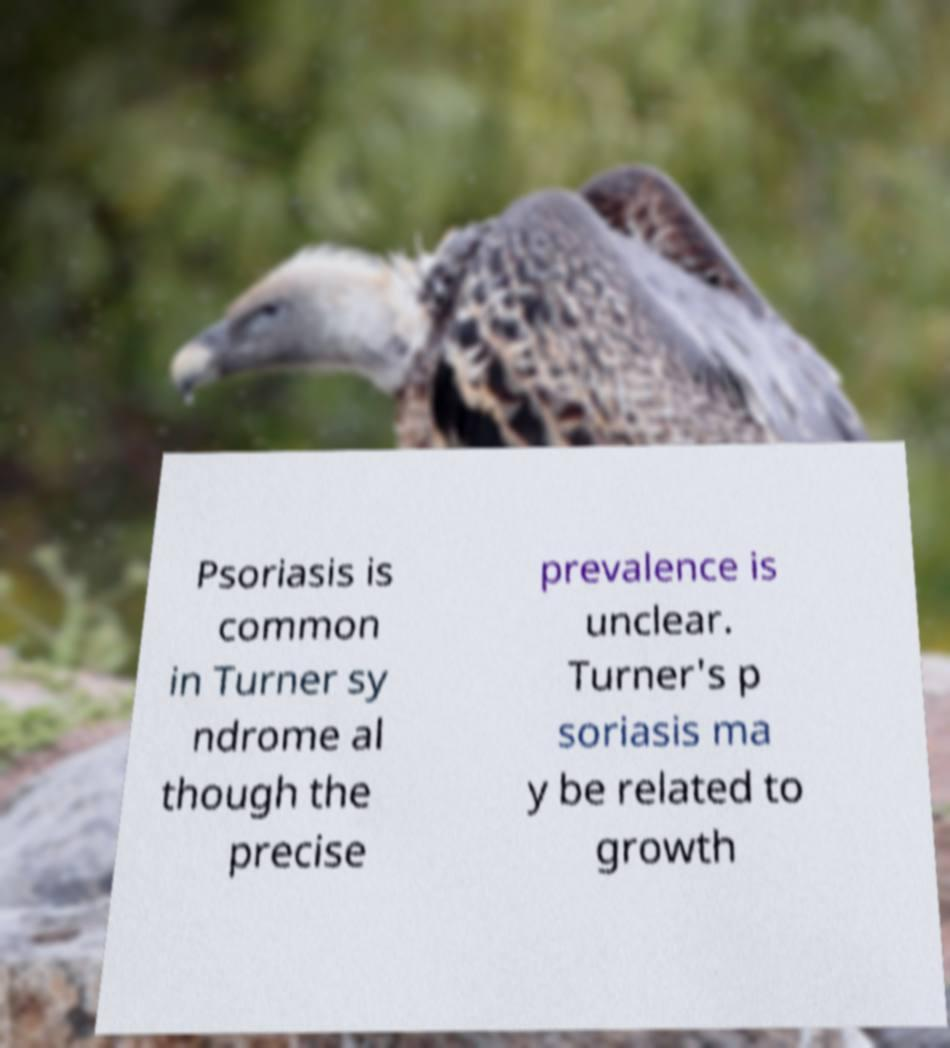Can you read and provide the text displayed in the image?This photo seems to have some interesting text. Can you extract and type it out for me? Psoriasis is common in Turner sy ndrome al though the precise prevalence is unclear. Turner's p soriasis ma y be related to growth 